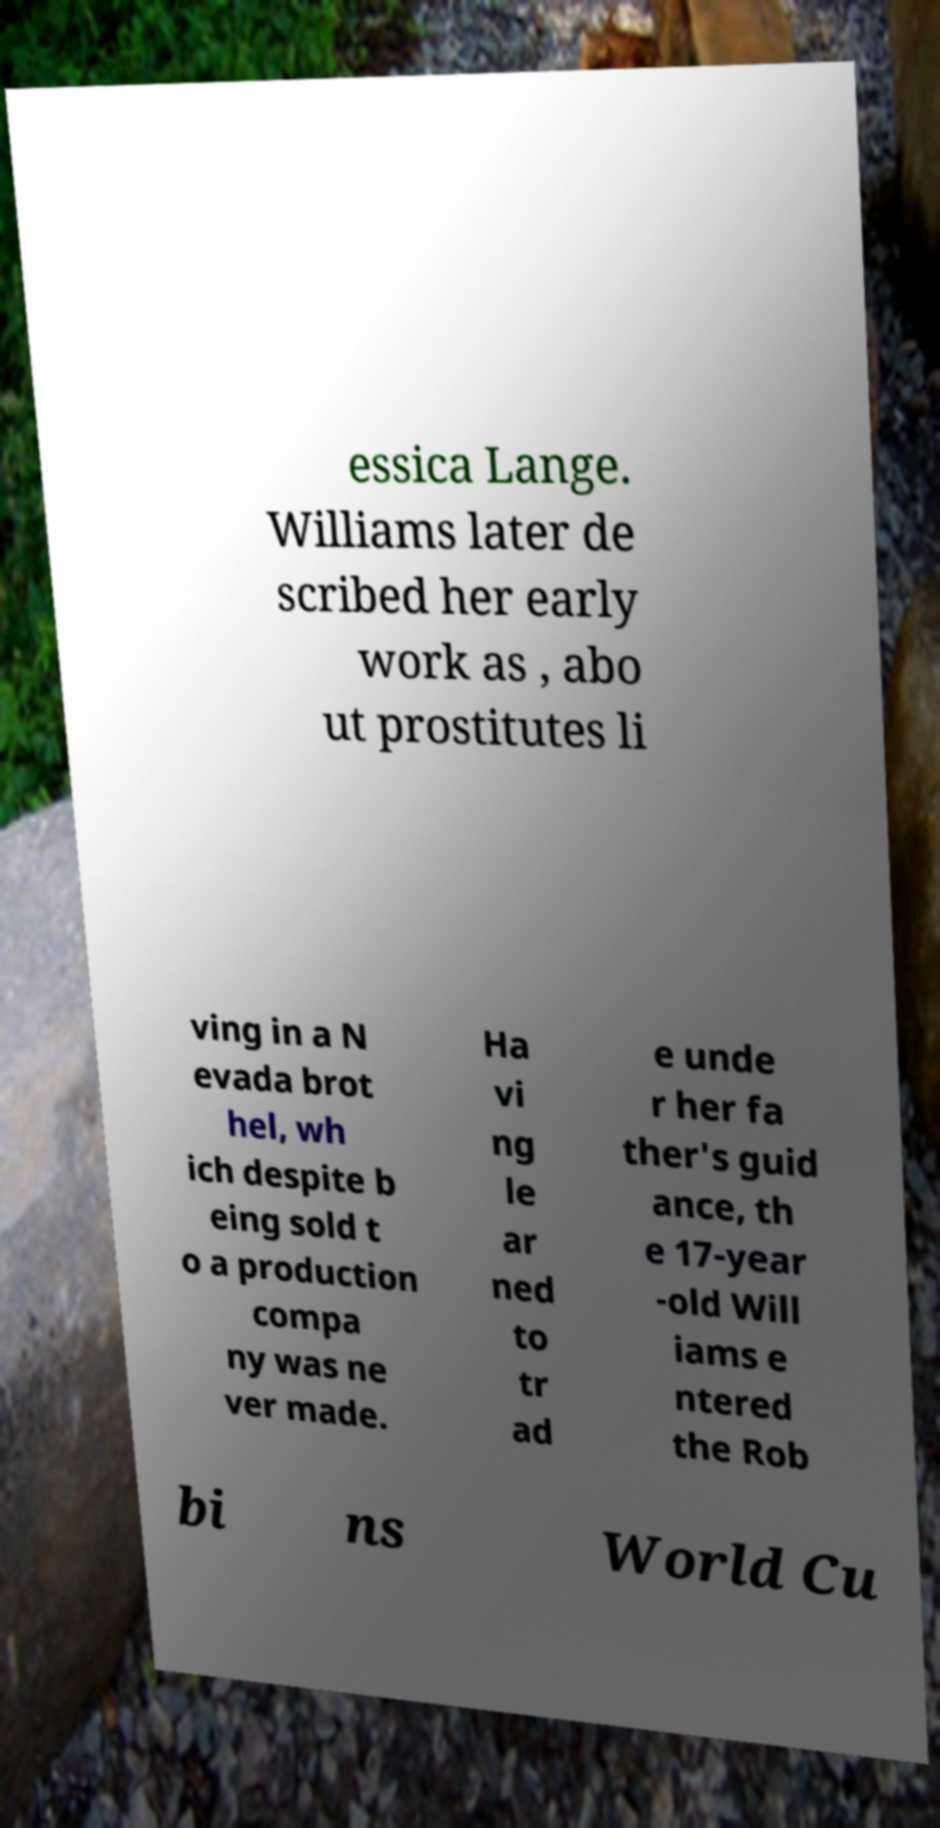What messages or text are displayed in this image? I need them in a readable, typed format. essica Lange. Williams later de scribed her early work as , abo ut prostitutes li ving in a N evada brot hel, wh ich despite b eing sold t o a production compa ny was ne ver made. Ha vi ng le ar ned to tr ad e unde r her fa ther's guid ance, th e 17-year -old Will iams e ntered the Rob bi ns World Cu 